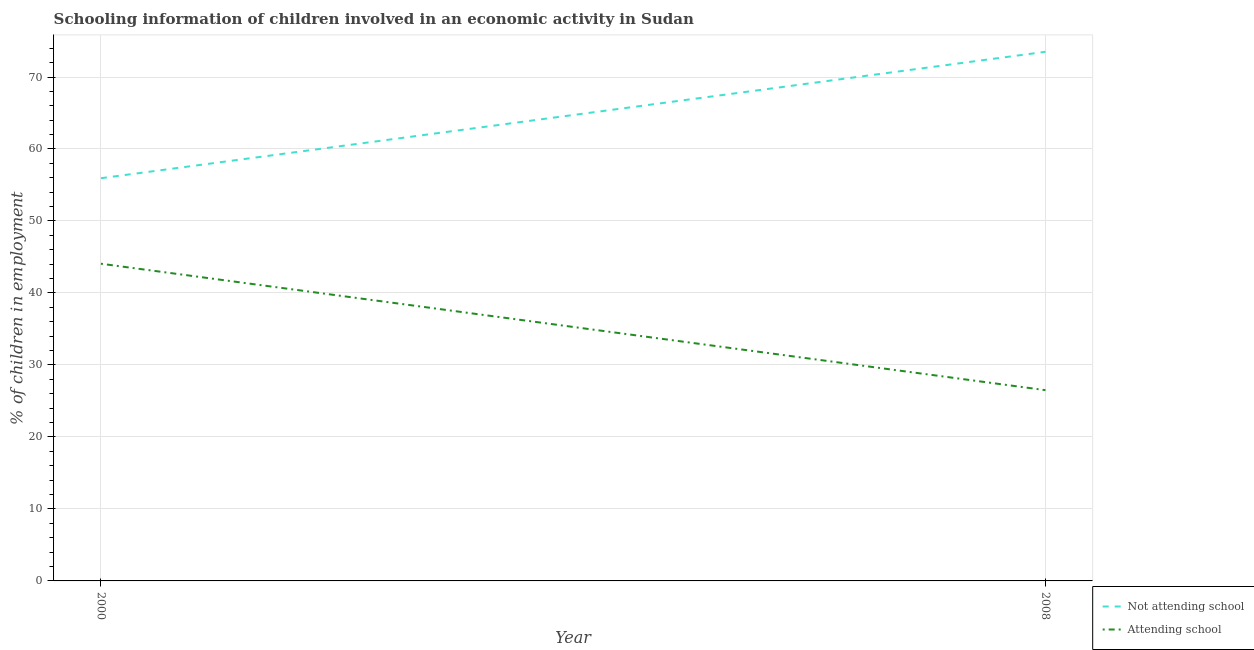How many different coloured lines are there?
Give a very brief answer. 2. Does the line corresponding to percentage of employed children who are attending school intersect with the line corresponding to percentage of employed children who are not attending school?
Provide a succinct answer. No. Is the number of lines equal to the number of legend labels?
Your answer should be very brief. Yes. What is the percentage of employed children who are not attending school in 2000?
Offer a terse response. 55.94. Across all years, what is the maximum percentage of employed children who are attending school?
Provide a succinct answer. 44.06. Across all years, what is the minimum percentage of employed children who are attending school?
Your answer should be compact. 26.5. What is the total percentage of employed children who are attending school in the graph?
Your answer should be very brief. 70.56. What is the difference between the percentage of employed children who are attending school in 2000 and that in 2008?
Provide a succinct answer. 17.56. What is the difference between the percentage of employed children who are not attending school in 2008 and the percentage of employed children who are attending school in 2000?
Ensure brevity in your answer.  29.44. What is the average percentage of employed children who are attending school per year?
Your answer should be very brief. 35.28. In the year 2008, what is the difference between the percentage of employed children who are not attending school and percentage of employed children who are attending school?
Provide a short and direct response. 47. In how many years, is the percentage of employed children who are not attending school greater than 68 %?
Your answer should be compact. 1. What is the ratio of the percentage of employed children who are attending school in 2000 to that in 2008?
Provide a short and direct response. 1.66. Is the percentage of employed children who are attending school in 2000 less than that in 2008?
Keep it short and to the point. No. Is the percentage of employed children who are not attending school strictly less than the percentage of employed children who are attending school over the years?
Your response must be concise. No. How many years are there in the graph?
Offer a very short reply. 2. Are the values on the major ticks of Y-axis written in scientific E-notation?
Keep it short and to the point. No. Does the graph contain any zero values?
Make the answer very short. No. How are the legend labels stacked?
Provide a succinct answer. Vertical. What is the title of the graph?
Your answer should be compact. Schooling information of children involved in an economic activity in Sudan. What is the label or title of the Y-axis?
Offer a terse response. % of children in employment. What is the % of children in employment of Not attending school in 2000?
Provide a succinct answer. 55.94. What is the % of children in employment of Attending school in 2000?
Give a very brief answer. 44.06. What is the % of children in employment in Not attending school in 2008?
Your answer should be very brief. 73.5. What is the % of children in employment in Attending school in 2008?
Your answer should be compact. 26.5. Across all years, what is the maximum % of children in employment in Not attending school?
Provide a succinct answer. 73.5. Across all years, what is the maximum % of children in employment of Attending school?
Provide a succinct answer. 44.06. Across all years, what is the minimum % of children in employment in Not attending school?
Offer a very short reply. 55.94. Across all years, what is the minimum % of children in employment in Attending school?
Make the answer very short. 26.5. What is the total % of children in employment in Not attending school in the graph?
Ensure brevity in your answer.  129.44. What is the total % of children in employment in Attending school in the graph?
Keep it short and to the point. 70.56. What is the difference between the % of children in employment of Not attending school in 2000 and that in 2008?
Your answer should be compact. -17.56. What is the difference between the % of children in employment in Attending school in 2000 and that in 2008?
Provide a succinct answer. 17.56. What is the difference between the % of children in employment in Not attending school in 2000 and the % of children in employment in Attending school in 2008?
Give a very brief answer. 29.44. What is the average % of children in employment in Not attending school per year?
Your response must be concise. 64.72. What is the average % of children in employment of Attending school per year?
Ensure brevity in your answer.  35.28. In the year 2000, what is the difference between the % of children in employment of Not attending school and % of children in employment of Attending school?
Offer a terse response. 11.88. In the year 2008, what is the difference between the % of children in employment of Not attending school and % of children in employment of Attending school?
Ensure brevity in your answer.  47. What is the ratio of the % of children in employment in Not attending school in 2000 to that in 2008?
Your response must be concise. 0.76. What is the ratio of the % of children in employment of Attending school in 2000 to that in 2008?
Provide a succinct answer. 1.66. What is the difference between the highest and the second highest % of children in employment in Not attending school?
Make the answer very short. 17.56. What is the difference between the highest and the second highest % of children in employment of Attending school?
Your answer should be very brief. 17.56. What is the difference between the highest and the lowest % of children in employment in Not attending school?
Provide a succinct answer. 17.56. What is the difference between the highest and the lowest % of children in employment in Attending school?
Keep it short and to the point. 17.56. 